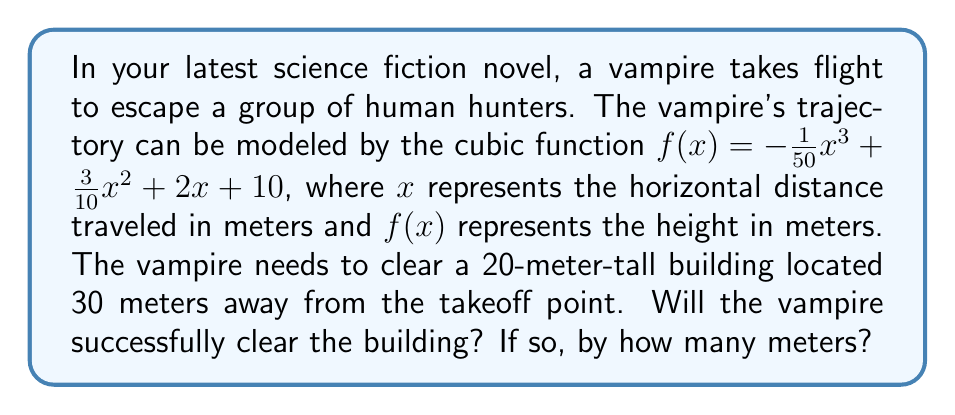Give your solution to this math problem. To solve this problem, we need to follow these steps:

1) First, we need to find the height of the vampire when $x = 30$ (the location of the building). We can do this by plugging $x = 30$ into our function:

   $f(30) = -\frac{1}{50}(30)^3 + \frac{3}{10}(30)^2 + 2(30) + 10$

2) Let's calculate this step by step:
   
   $-\frac{1}{50}(30)^3 = -540$
   $\frac{3}{10}(30)^2 = 270$
   $2(30) = 60$
   $10$ remains as is

3) Adding these up:

   $f(30) = -540 + 270 + 60 + 10 = -200$

4) The height of the vampire at $x = 30$ is -200 meters. However, this is below ground level, which doesn't make sense in the context of the problem. This means the vampire has already landed before reaching the building.

5) To find where the vampire lands, we need to find the root of the equation that occurs before $x = 30$. We can do this by graphing the function or using numerical methods, but for simplicity, let's estimate it to be around $x = 25$ meters.

6) Therefore, the vampire will not clear the building as they will land before reaching it.
Answer: No, the vampire will not clear the building. The vampire will land approximately 25 meters from the takeoff point, which is 5 meters short of the building. 